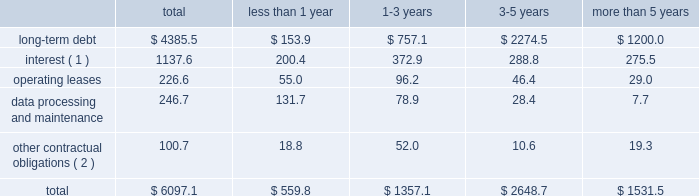Contractual obligations fis 2019 long-term contractual obligations generally include its long-term debt , interest on long-term debt , lease payments on certain of its property and equipment and payments for data processing and maintenance .
For more descriptive information regarding the company's long-term debt , see note 13 in the notes to consolidated financial statements .
The table summarizes fis 2019 significant contractual obligations and commitments as of december 31 , 2012 ( in millions ) : less than 1-3 3-5 more than total 1 year years years 5 years .
( 1 ) these calculations assume that : ( a ) applicable margins remain constant ; ( b ) all variable rate debt is priced at the one-month libor rate in effect as of december 31 , 2012 ; ( c ) no new hedging transactions are effected ; ( d ) only mandatory debt repayments are made ; and ( e ) no refinancing occurs at debt maturity .
( 2 ) amount includes the payment for labor claims related to fis' former item processing and remittance operations in brazil ( see note 3 to the consolidated financial statements ) and amounts due to the brazilian venture partner .
Fis believes that its existing cash balances , cash flows from operations and borrowing programs will provide adequate sources of liquidity and capital resources to meet fis 2019 expected short-term liquidity needs and its long-term needs for the operations of its business , expected capital spending for the next 12 months and the foreseeable future and the satisfaction of these obligations and commitments .
Off-balance sheet arrangements fis does not have any off-balance sheet arrangements .
Item 7a .
Quantitative and qualitative disclosure about market risks market risk we are exposed to market risks primarily from changes in interest rates and foreign currency exchange rates .
We use certain derivative financial instruments , including interest rate swaps and foreign currency forward exchange contracts , to manage interest rate and foreign currency risk .
We do not use derivatives for trading purposes , to generate income or to engage in speculative activity .
Interest rate risk in addition to existing cash balances and cash provided by operating activities , we use fixed rate and variable rate debt to finance our operations .
We are exposed to interest rate risk on these debt obligations and related interest rate swaps .
The notes ( as defined in note 13 to the consolidated financial statements ) represent substantially all of our fixed-rate long-term debt obligations .
The carrying value of the notes was $ 1950.0 million as of december 31 , 2012 .
The fair value of the notes was approximately $ 2138.2 million as of december 31 , 2012 .
The potential reduction in fair value of the notes from a hypothetical 10 percent increase in market interest rates would not be material to the overall fair value of the debt .
Our floating rate long-term debt obligations principally relate to borrowings under the fis credit agreement ( as also defined in note 13 to the consolidated financial statements ) .
An increase of 100 basis points in the libor rate would increase our annual debt service under the fis credit agreement , after we include the impact of our interest rate swaps , by $ 9.3 million ( based on principal amounts outstanding as of december 31 , 2012 ) .
We performed the foregoing sensitivity analysis based on the principal amount of our floating rate debt as of december 31 , 2012 , less the principal amount of such debt that was then subject to an interest rate swap converting such debt into fixed rate debt .
This sensitivity analysis is based solely on .
What percent of total contractual obligations and commitments as of december 31 , 2012 are long-term debt? 
Computations: (4385.5 / 6097.1)
Answer: 0.71928. 